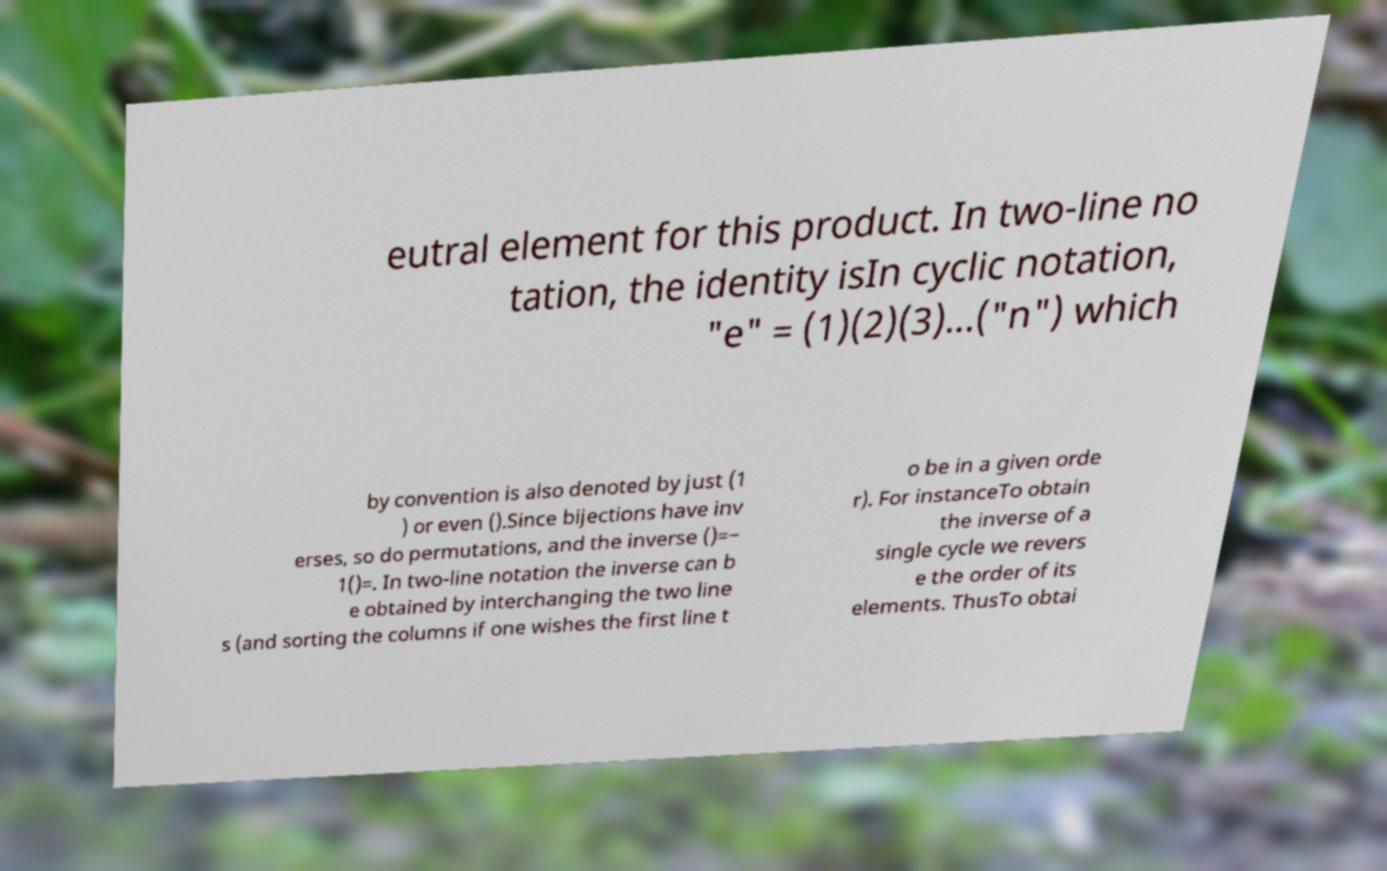Could you extract and type out the text from this image? eutral element for this product. In two-line no tation, the identity isIn cyclic notation, "e" = (1)(2)(3)...("n") which by convention is also denoted by just (1 ) or even ().Since bijections have inv erses, so do permutations, and the inverse ()=− 1()=. In two-line notation the inverse can b e obtained by interchanging the two line s (and sorting the columns if one wishes the first line t o be in a given orde r). For instanceTo obtain the inverse of a single cycle we revers e the order of its elements. ThusTo obtai 